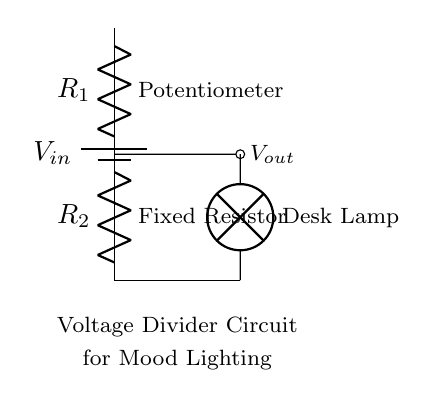what type of circuit is shown? The circuit shown is a voltage divider circuit, which divides the input voltage into smaller output voltages based on the resistances in series.
Answer: voltage divider what are the components used in the circuit? The components used in the circuit are a potentiometer, a fixed resistor, a battery, and a lamp.
Answer: potentiometer, fixed resistor, battery, lamp what is the purpose of the potentiometer in this circuit? The purpose of the potentiometer is to adjust the resistance in the circuit, which allows the user to control the output voltage and thus dim the lamp for mood lighting.
Answer: adjust resistance what is the relationship between R1 and R2 for voltage output? The output voltage is determined by the ratio of R1 (potentiometer) to the total resistance of R1 and R2, impacting how much voltage is dropped across R2.
Answer: R1/R2 ratio how can you increase the lamp’s brightness? To increase the lamp’s brightness, you can decrease the resistance of R1 (the potentiometer), which will allow more current to flow through the lamp, increasing its brightness.
Answer: decrease R1 what happens if R2 is removed from the circuit? If R2 is removed, the circuit will no longer act as a voltage divider, and the output voltage will equal the input voltage; this could potentially damage the lamp.
Answer: equal input voltage what effect does increasing the total resistance of R1 and R2 have on the brightness? Increasing the total resistance of R1 and R2 will reduce the current flowing through the lamp, resulting in lower brightness.
Answer: reduces brightness 